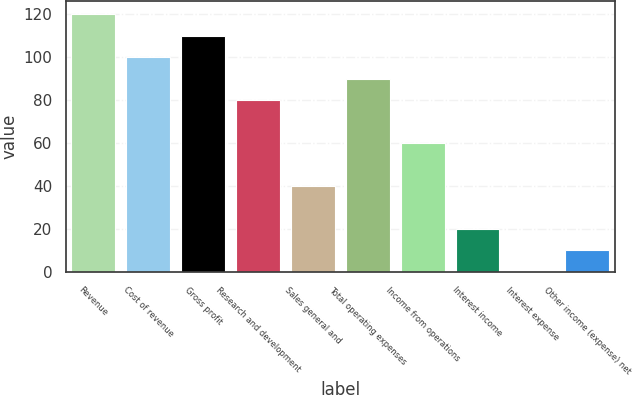<chart> <loc_0><loc_0><loc_500><loc_500><bar_chart><fcel>Revenue<fcel>Cost of revenue<fcel>Gross profit<fcel>Research and development<fcel>Sales general and<fcel>Total operating expenses<fcel>Income from operations<fcel>Interest income<fcel>Interest expense<fcel>Other income (expense) net<nl><fcel>119.98<fcel>100<fcel>109.99<fcel>80.02<fcel>40.06<fcel>90.01<fcel>60.04<fcel>20.08<fcel>0.1<fcel>10.09<nl></chart> 